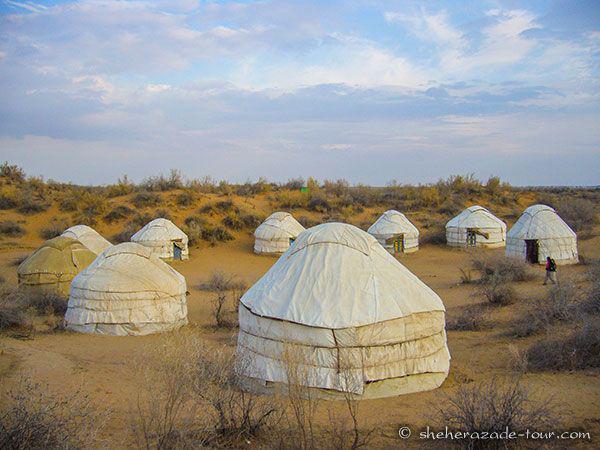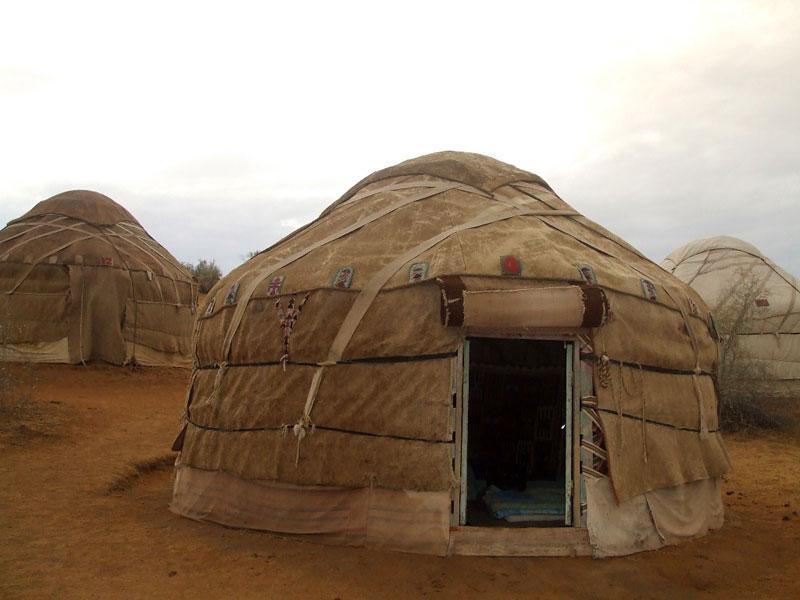The first image is the image on the left, the second image is the image on the right. Analyze the images presented: Is the assertion "An image shows a group of round structures covered in brown material crossed with straps." valid? Answer yes or no. Yes. The first image is the image on the left, the second image is the image on the right. Given the left and right images, does the statement "At least seven yurts of the same style are shown in a scrubby dessert setting in one image, while a second image shows at least 2 yurts." hold true? Answer yes or no. Yes. 